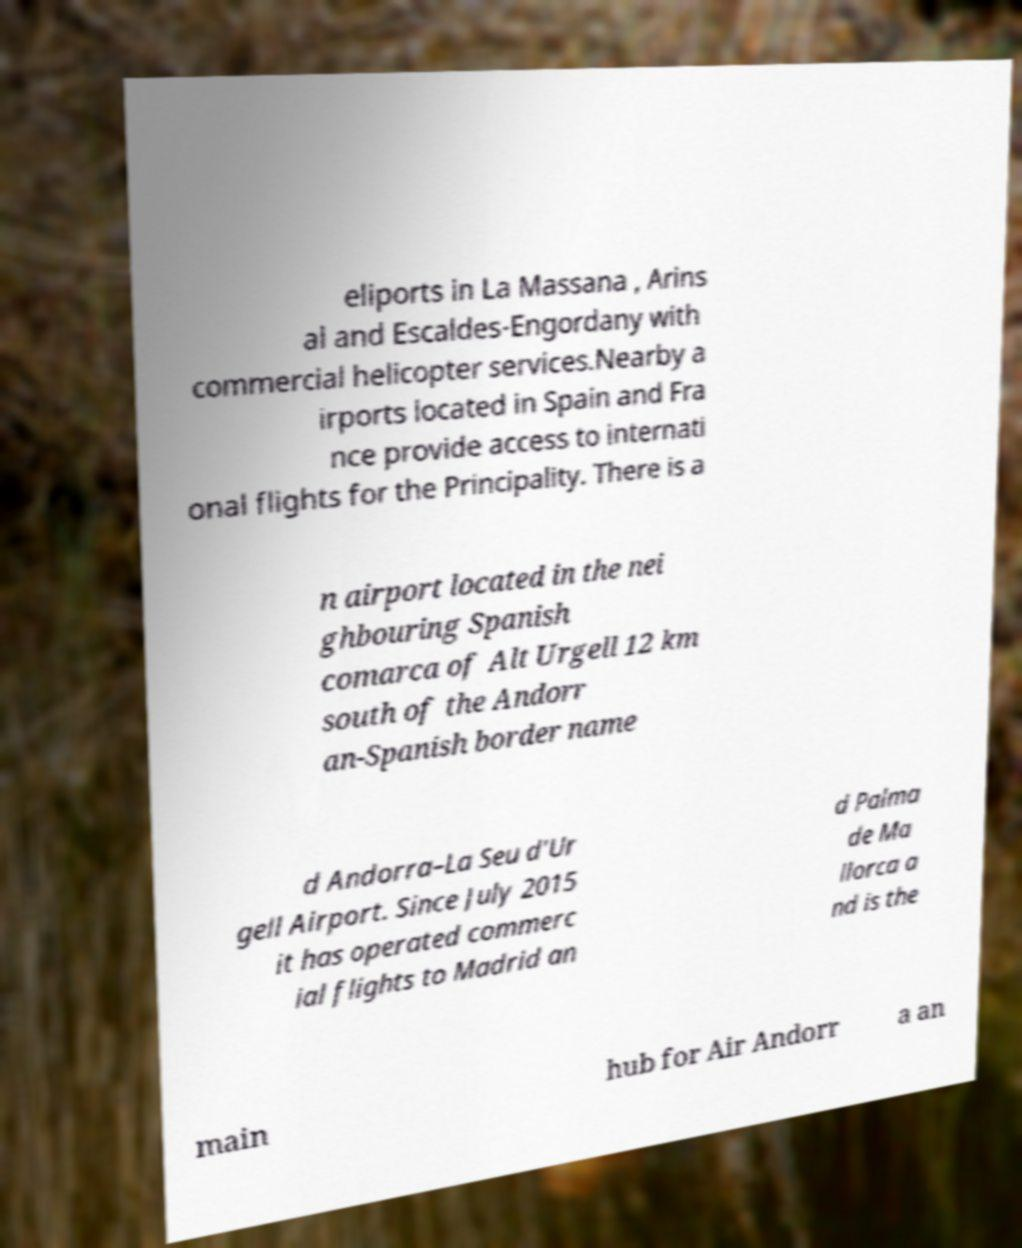Please identify and transcribe the text found in this image. eliports in La Massana , Arins al and Escaldes-Engordany with commercial helicopter services.Nearby a irports located in Spain and Fra nce provide access to internati onal flights for the Principality. There is a n airport located in the nei ghbouring Spanish comarca of Alt Urgell 12 km south of the Andorr an-Spanish border name d Andorra–La Seu d'Ur gell Airport. Since July 2015 it has operated commerc ial flights to Madrid an d Palma de Ma llorca a nd is the main hub for Air Andorr a an 